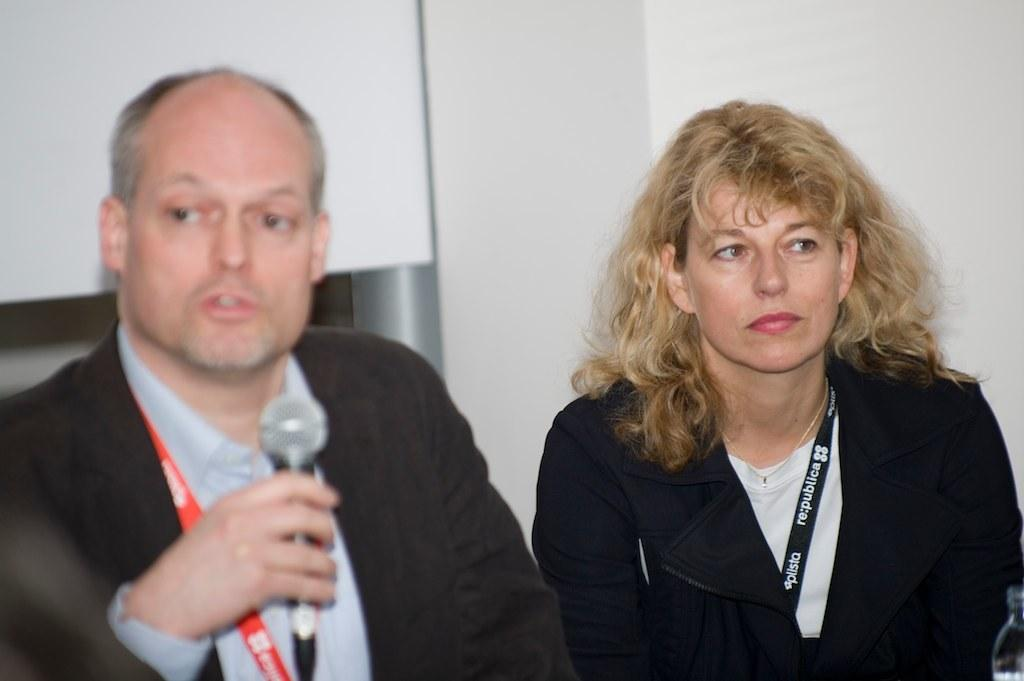What is the man in the image wearing? The man is wearing a suit. What is the man holding in the image? The man is holding a microphone. What is the woman in the image wearing? The woman is wearing a jacket. What is the woman doing in the image? The woman is staring. What type of creature is participating in the competition in the image? There is no competition or creature present in the image. 